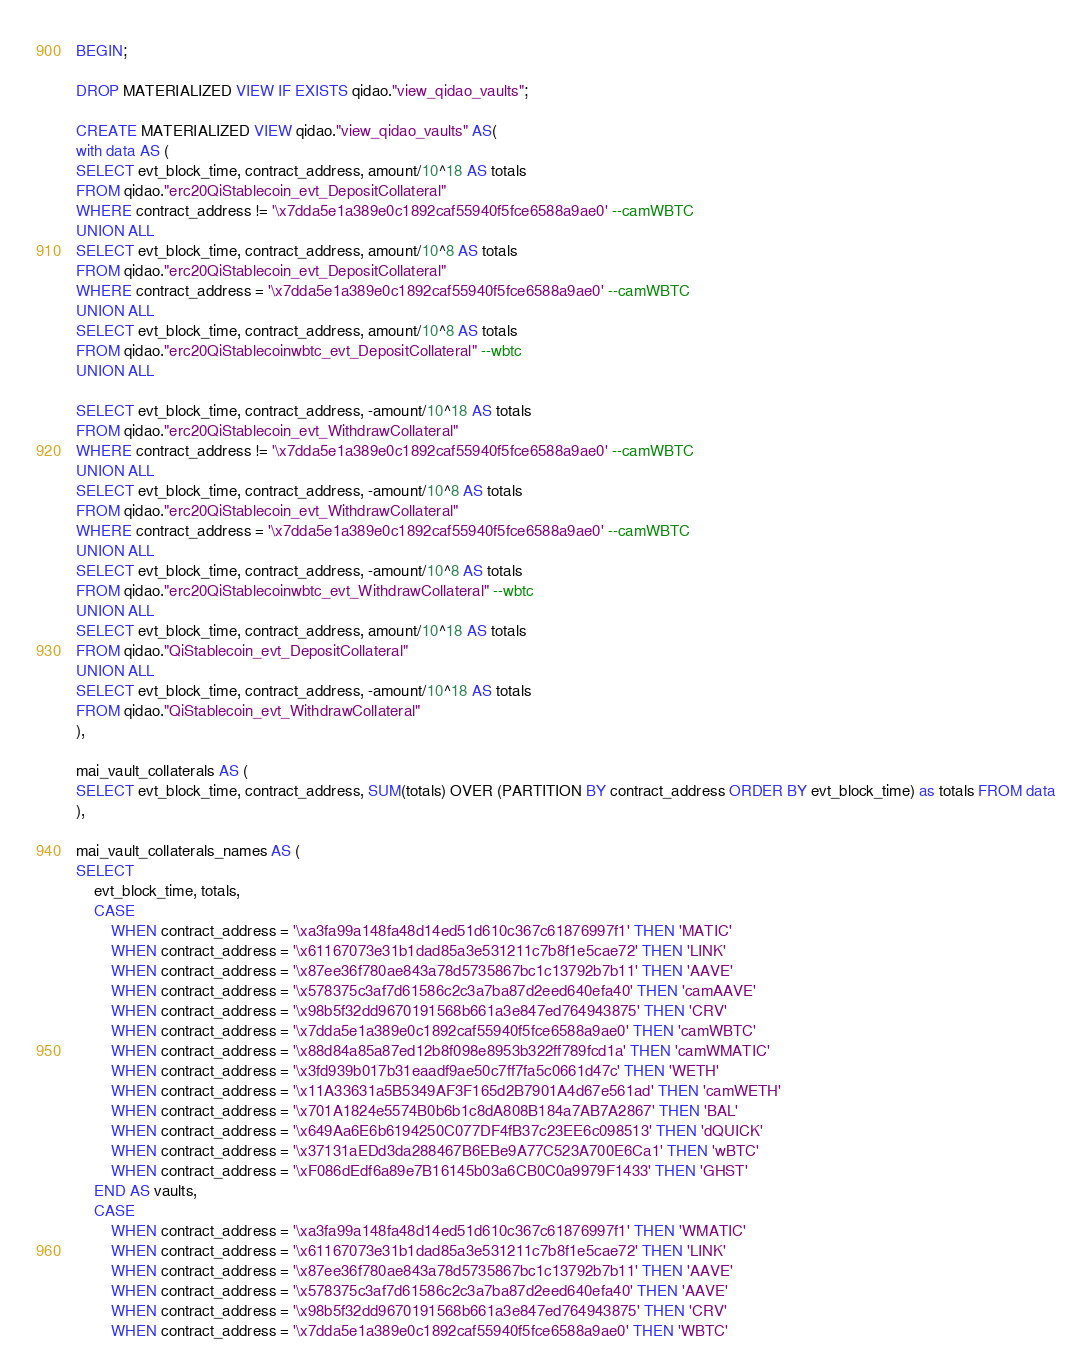<code> <loc_0><loc_0><loc_500><loc_500><_SQL_>BEGIN;

DROP MATERIALIZED VIEW IF EXISTS qidao."view_qidao_vaults";

CREATE MATERIALIZED VIEW qidao."view_qidao_vaults" AS(
with data AS (
SELECT evt_block_time, contract_address, amount/10^18 AS totals 
FROM qidao."erc20QiStablecoin_evt_DepositCollateral"
WHERE contract_address != '\x7dda5e1a389e0c1892caf55940f5fce6588a9ae0' --camWBTC
UNION ALL
SELECT evt_block_time, contract_address, amount/10^8 AS totals 
FROM qidao."erc20QiStablecoin_evt_DepositCollateral"
WHERE contract_address = '\x7dda5e1a389e0c1892caf55940f5fce6588a9ae0' --camWBTC
UNION ALL
SELECT evt_block_time, contract_address, amount/10^8 AS totals 
FROM qidao."erc20QiStablecoinwbtc_evt_DepositCollateral" --wbtc
UNION ALL

SELECT evt_block_time, contract_address, -amount/10^18 AS totals  
FROM qidao."erc20QiStablecoin_evt_WithdrawCollateral"
WHERE contract_address != '\x7dda5e1a389e0c1892caf55940f5fce6588a9ae0' --camWBTC
UNION ALL
SELECT evt_block_time, contract_address, -amount/10^8 AS totals  
FROM qidao."erc20QiStablecoin_evt_WithdrawCollateral"
WHERE contract_address = '\x7dda5e1a389e0c1892caf55940f5fce6588a9ae0' --camWBTC
UNION ALL
SELECT evt_block_time, contract_address, -amount/10^8 AS totals  
FROM qidao."erc20QiStablecoinwbtc_evt_WithdrawCollateral" --wbtc
UNION ALL
SELECT evt_block_time, contract_address, amount/10^18 AS totals 
FROM qidao."QiStablecoin_evt_DepositCollateral"
UNION ALL
SELECT evt_block_time, contract_address, -amount/10^18 AS totals 
FROM qidao."QiStablecoin_evt_WithdrawCollateral"
),

mai_vault_collaterals AS (
SELECT evt_block_time, contract_address, SUM(totals) OVER (PARTITION BY contract_address ORDER BY evt_block_time) as totals FROM data
),

mai_vault_collaterals_names AS (
SELECT 
    evt_block_time, totals,
    CASE 
        WHEN contract_address = '\xa3fa99a148fa48d14ed51d610c367c61876997f1' THEN 'MATIC'
        WHEN contract_address = '\x61167073e31b1dad85a3e531211c7b8f1e5cae72' THEN 'LINK'
        WHEN contract_address = '\x87ee36f780ae843a78d5735867bc1c13792b7b11' THEN 'AAVE'
        WHEN contract_address = '\x578375c3af7d61586c2c3a7ba87d2eed640efa40' THEN 'camAAVE'
        WHEN contract_address = '\x98b5f32dd9670191568b661a3e847ed764943875' THEN 'CRV'
        WHEN contract_address = '\x7dda5e1a389e0c1892caf55940f5fce6588a9ae0' THEN 'camWBTC'
        WHEN contract_address = '\x88d84a85a87ed12b8f098e8953b322ff789fcd1a' THEN 'camWMATIC'
        WHEN contract_address = '\x3fd939b017b31eaadf9ae50c7ff7fa5c0661d47c' THEN 'WETH'
        WHEN contract_address = '\x11A33631a5B5349AF3F165d2B7901A4d67e561ad' THEN 'camWETH'
        WHEN contract_address = '\x701A1824e5574B0b6b1c8dA808B184a7AB7A2867' THEN 'BAL'
        WHEN contract_address = '\x649Aa6E6b6194250C077DF4fB37c23EE6c098513' THEN 'dQUICK'
        WHEN contract_address = '\x37131aEDd3da288467B6EBe9A77C523A700E6Ca1' THEN 'wBTC'
        WHEN contract_address = '\xF086dEdf6a89e7B16145b03a6CB0C0a9979F1433' THEN 'GHST'
    END AS vaults,
    CASE 
        WHEN contract_address = '\xa3fa99a148fa48d14ed51d610c367c61876997f1' THEN 'WMATIC'
        WHEN contract_address = '\x61167073e31b1dad85a3e531211c7b8f1e5cae72' THEN 'LINK'
        WHEN contract_address = '\x87ee36f780ae843a78d5735867bc1c13792b7b11' THEN 'AAVE'
        WHEN contract_address = '\x578375c3af7d61586c2c3a7ba87d2eed640efa40' THEN 'AAVE'
        WHEN contract_address = '\x98b5f32dd9670191568b661a3e847ed764943875' THEN 'CRV'
        WHEN contract_address = '\x7dda5e1a389e0c1892caf55940f5fce6588a9ae0' THEN 'WBTC'</code> 